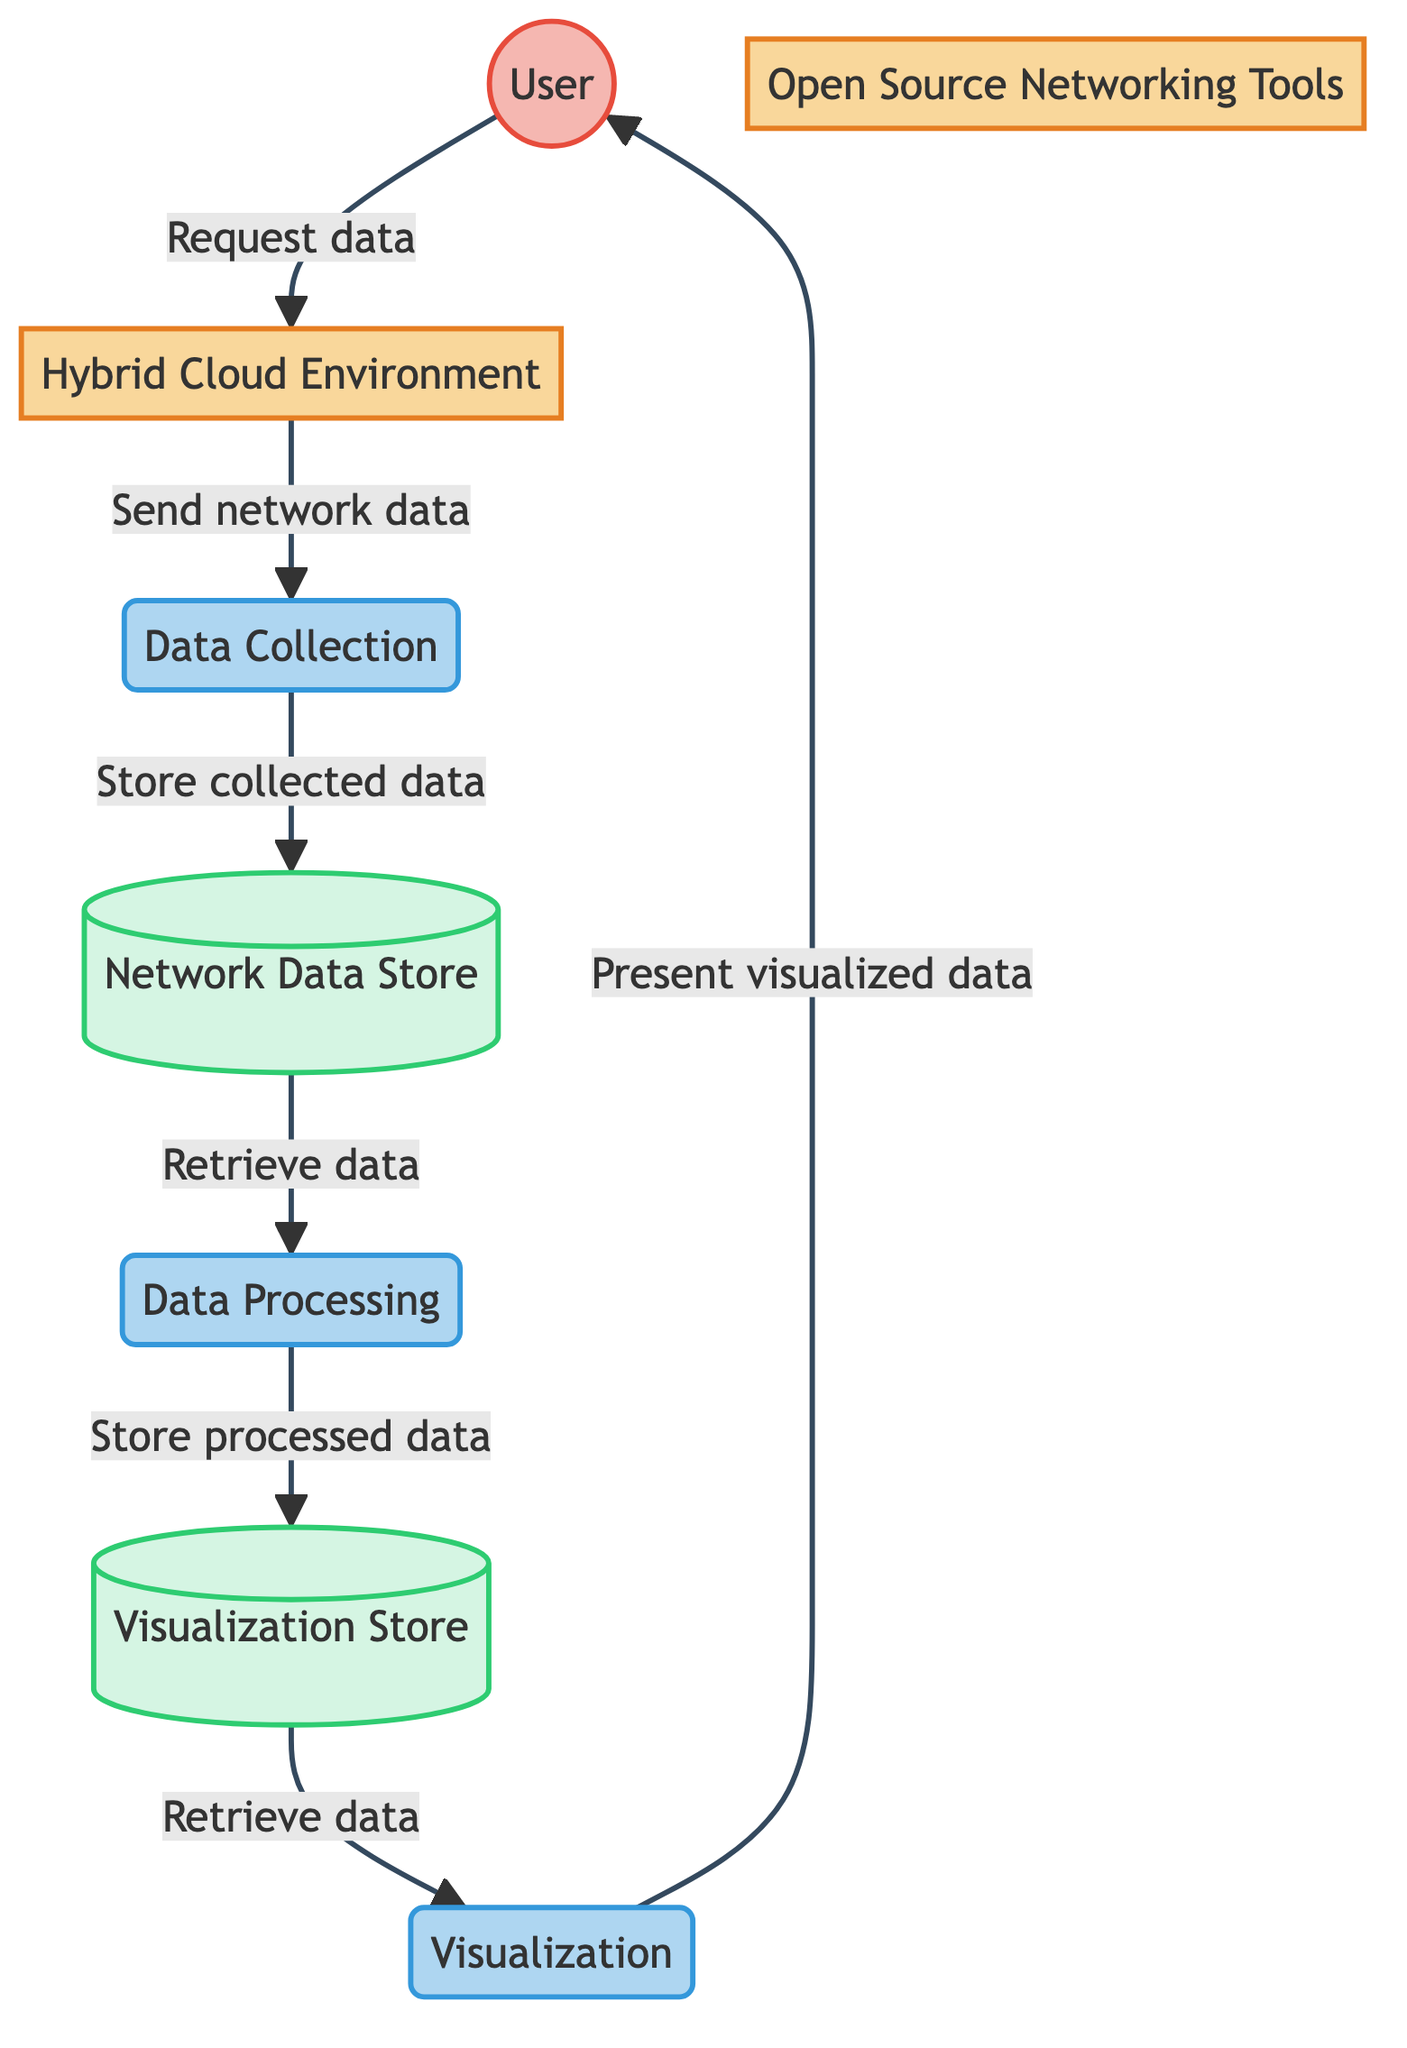What is the first process in the data flow? The first process in the data flow is "Data Collection," as depicted in the diagram where it is the first labeled process following the "Hybrid Cloud Environment" node.
Answer: Data Collection How many data stores are present in the diagram? The diagram contains two data stores, namely "Network Data Store" and "Visualization Store," as indicated by the respective nodes labeled in the data stores section.
Answer: Two From which entity does the "Data Collection" process receive network data? "Data Collection" receives network data from the "Hybrid Cloud Environment," as shown by the directed flow from the "Hybrid Cloud Environment" node to the "Data Collection" process node.
Answer: Hybrid Cloud Environment What type of tools are utilized in the Data Processing process? The Data Processing process utilizes "Open Source Networking Tools," as indicated by the direct connection from the "Open Source Networking Tools" system to the "Data Processing" process node.
Answer: Open Source Networking Tools Which process stores processed data for visualization? The process that stores the processed data for visualization is "Data Processing," as indicated by the flow leading from "Data Processing" to the "Visualization Store" data store.
Answer: Data Processing What is the relationship between the "User" and the "Hybrid Cloud Environment"? The relationship is that the "User" sends a request for data to the "Hybrid Cloud Environment," as indicated by the directed flow that connects the two nodes in the diagram.
Answer: User requests data What does the "Visualization" process present to the user? The "Visualization" process presents visualized data to the user, which is explicitly stated in the flow going from "Visualization" to "User" in the diagram.
Answer: Visualized data Which node stores the collected network data? The node that stores the collected network data is "Network Data Store," which is connected to the "Data Collection" process by directed data flow for storing the data.
Answer: Network Data Store What happens after data is retrieved from the "Visualization Store"? After data is retrieved from the "Visualization Store," it is sent to the "Visualization" process, as indicated by the flow direction from the "Visualization Store" to the "Visualization" process.
Answer: Sent to Visualization 